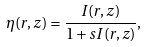<formula> <loc_0><loc_0><loc_500><loc_500>\eta ( r , z ) = \frac { I ( r , z ) } { 1 + s I ( r , z ) } ,</formula> 